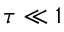<formula> <loc_0><loc_0><loc_500><loc_500>\tau \ll 1</formula> 